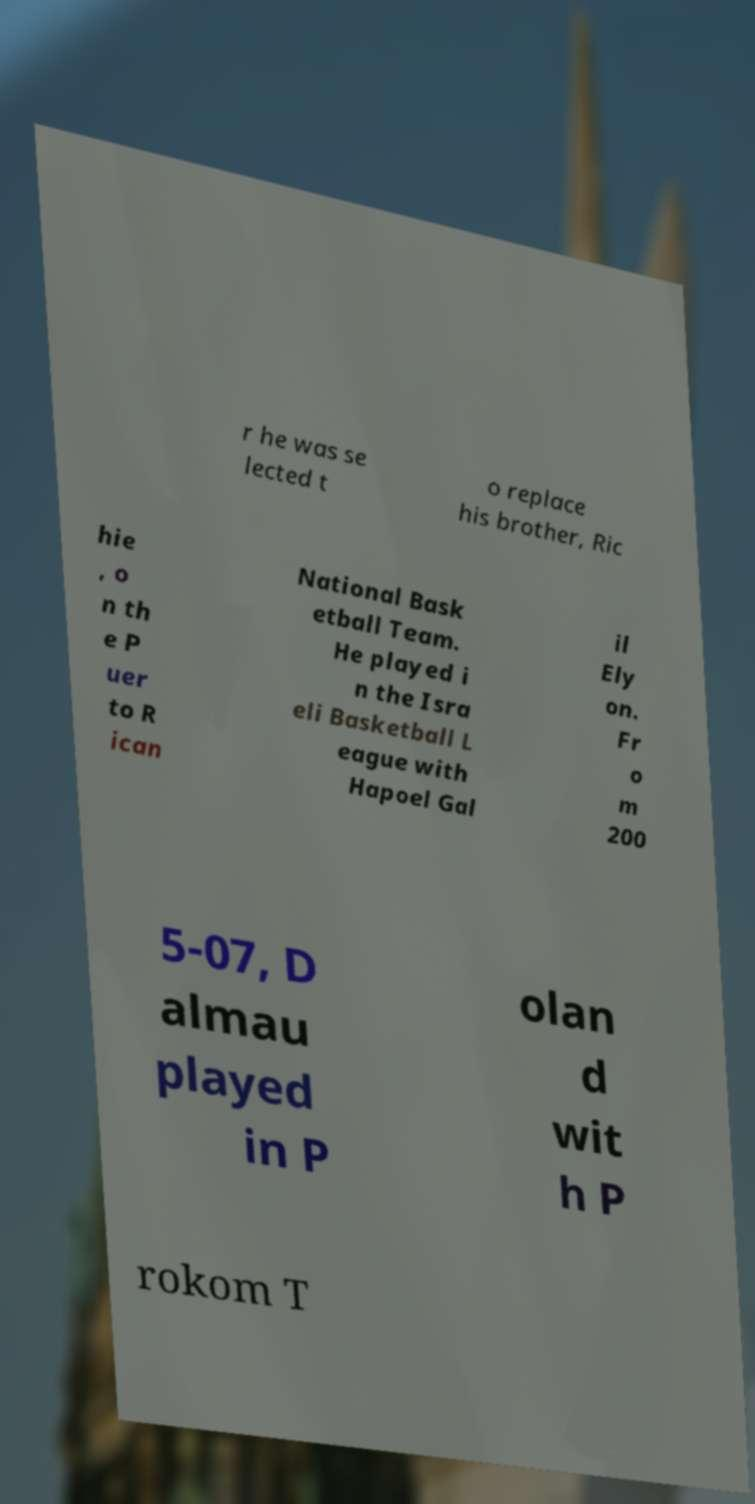There's text embedded in this image that I need extracted. Can you transcribe it verbatim? r he was se lected t o replace his brother, Ric hie , o n th e P uer to R ican National Bask etball Team. He played i n the Isra eli Basketball L eague with Hapoel Gal il Ely on. Fr o m 200 5-07, D almau played in P olan d wit h P rokom T 